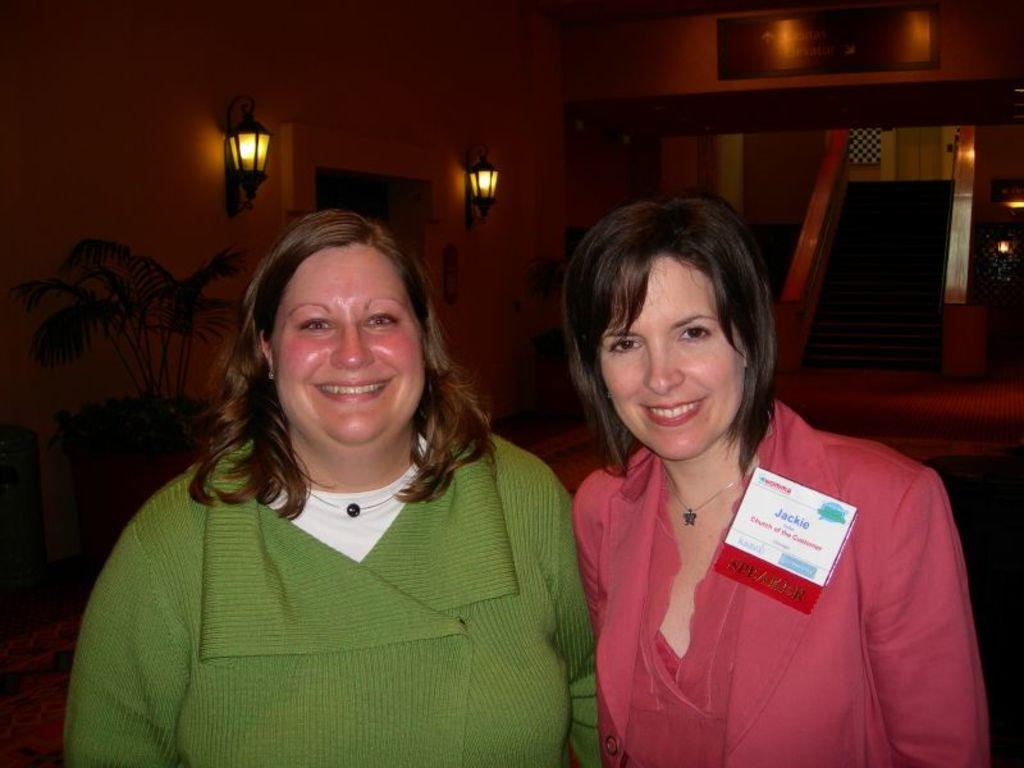How many people are present in the image? There are two people standing in the image. What can be seen on the wall in the image? There is a frame on the wall in the image. Are there any lights in the image? Yes, there are lights attached to the wall in the image. What architectural feature is visible in the image? There are stairs visible in the image. What type of plant is present in the image? There is a potted plant in the image. What type of machine is being used by the people in the image? There is no machine present in the image; it only shows two people standing, a frame on the wall, lights, stairs, and a potted plant. 